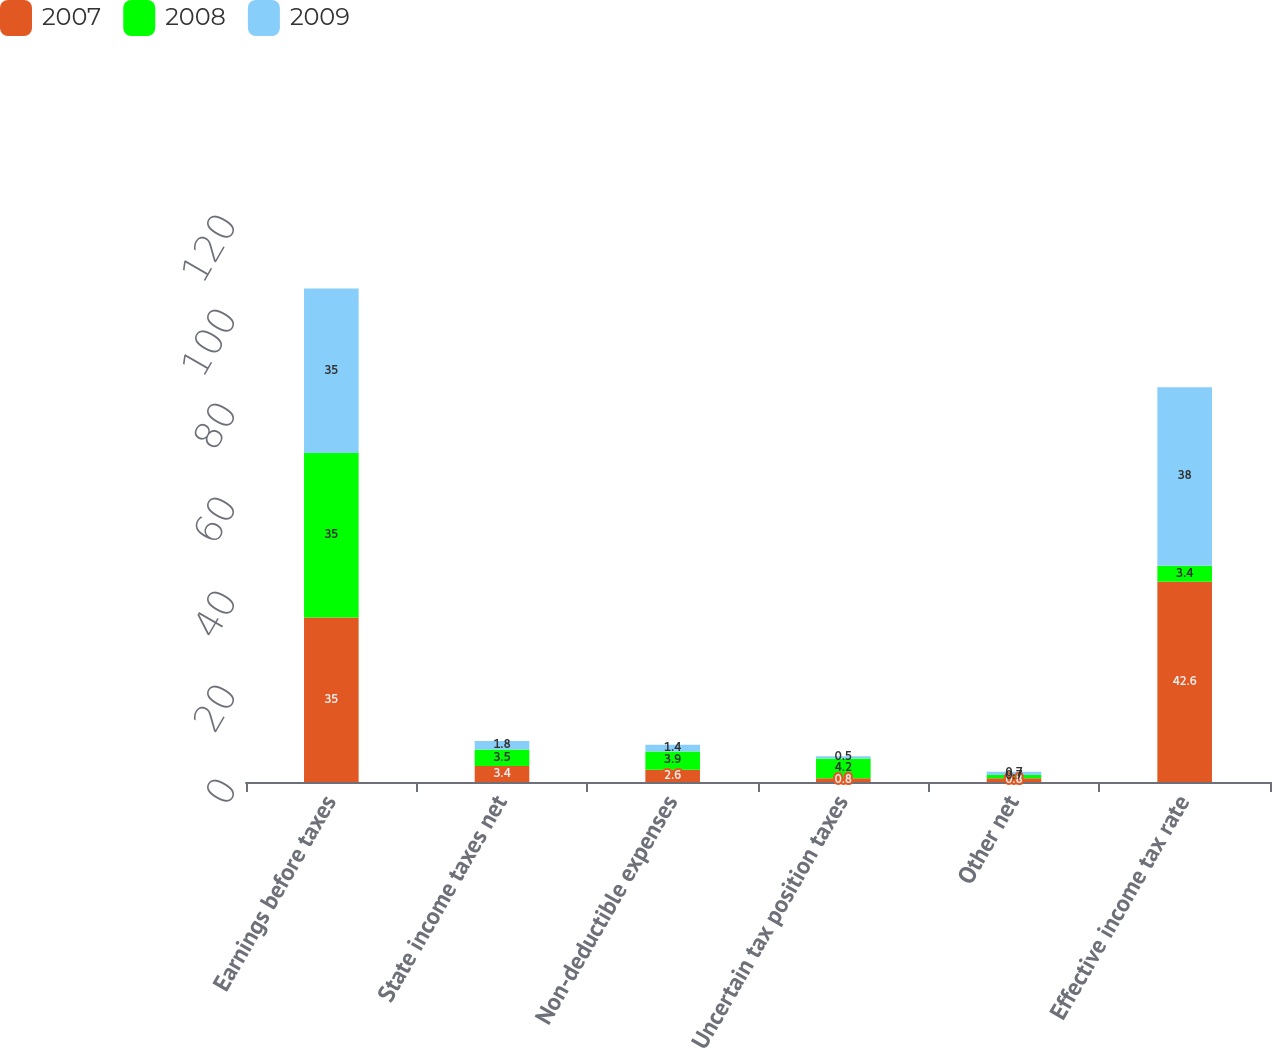<chart> <loc_0><loc_0><loc_500><loc_500><stacked_bar_chart><ecel><fcel>Earnings before taxes<fcel>State income taxes net<fcel>Non-deductible expenses<fcel>Uncertain tax position taxes<fcel>Other net<fcel>Effective income tax rate<nl><fcel>2007<fcel>35<fcel>3.4<fcel>2.6<fcel>0.8<fcel>0.8<fcel>42.6<nl><fcel>2008<fcel>35<fcel>3.5<fcel>3.9<fcel>4.2<fcel>0.7<fcel>3.4<nl><fcel>2009<fcel>35<fcel>1.8<fcel>1.4<fcel>0.5<fcel>0.7<fcel>38<nl></chart> 